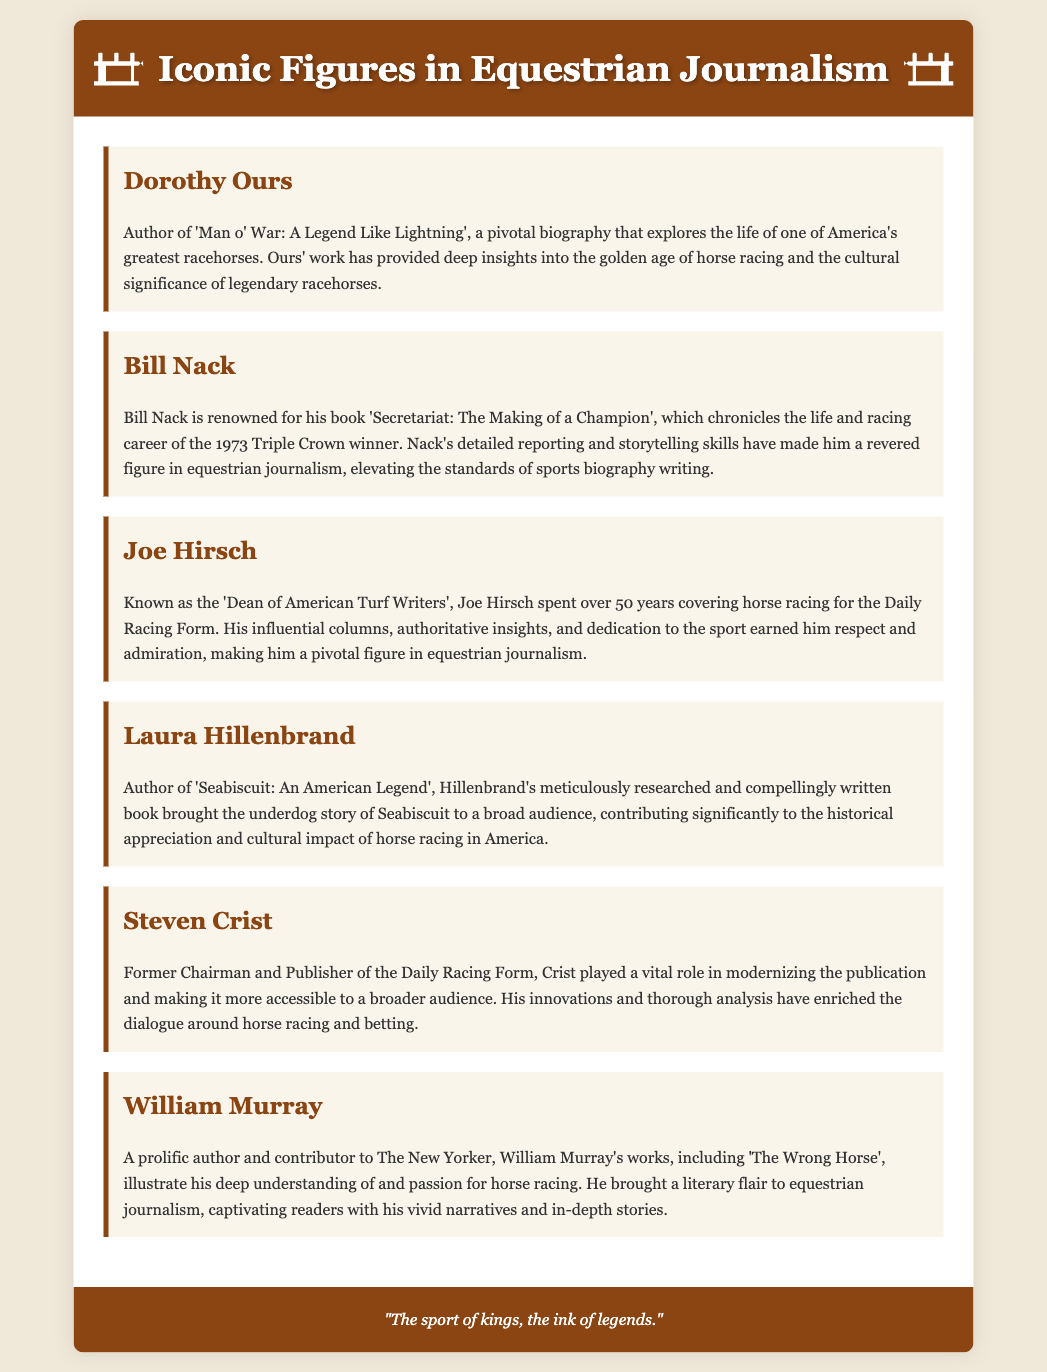What is Dorothy Ours known for? Dorothy Ours is known for authoring 'Man o' War: A Legend Like Lightning', a pivotal biography that explores the life of one of America's greatest racehorses.
Answer: 'Man o' War: A Legend Like Lightning' Who wrote 'Secretariat: The Making of a Champion'? 'Secretariat: The Making of a Champion' was written by Bill Nack, which chronicles the life and racing career of the 1973 Triple Crown winner.
Answer: Bill Nack How many years did Joe Hirsch cover horse racing? Joe Hirsch spent over 50 years covering horse racing for the Daily Racing Form.
Answer: 50 years What book did Laura Hillenbrand author? Laura Hillenbrand is the author of 'Seabiscuit: An American Legend', which contributed significantly to the cultural impact of horse racing.
Answer: 'Seabiscuit: An American Legend' What role did Steven Crist hold at the Daily Racing Form? Steven Crist was the former Chairman and Publisher of the Daily Racing Form, playing a vital role in modernizing the publication.
Answer: Chairman and Publisher Which author contributed to The New Yorker? William Murray contributed to The New Yorker and is noted for his works that illustrate his deep understanding of horse racing.
Answer: William Murray What is the common theme among the works of these journalists? The common theme among the works is the exploration and celebration of horse racing culture and history through detailed narratives.
Answer: Horse racing culture and history What is the footer quote in the document? The footer quote in the document states, "The sport of kings, the ink of legends."
Answer: "The sport of kings, the ink of legends." 